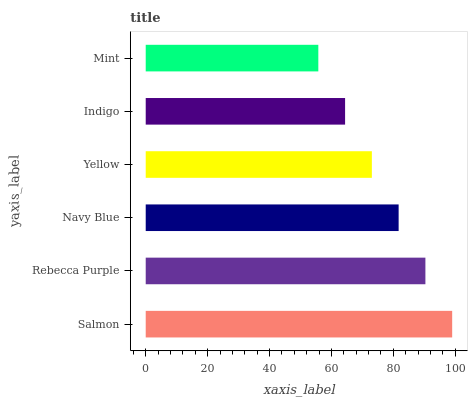Is Mint the minimum?
Answer yes or no. Yes. Is Salmon the maximum?
Answer yes or no. Yes. Is Rebecca Purple the minimum?
Answer yes or no. No. Is Rebecca Purple the maximum?
Answer yes or no. No. Is Salmon greater than Rebecca Purple?
Answer yes or no. Yes. Is Rebecca Purple less than Salmon?
Answer yes or no. Yes. Is Rebecca Purple greater than Salmon?
Answer yes or no. No. Is Salmon less than Rebecca Purple?
Answer yes or no. No. Is Navy Blue the high median?
Answer yes or no. Yes. Is Yellow the low median?
Answer yes or no. Yes. Is Indigo the high median?
Answer yes or no. No. Is Mint the low median?
Answer yes or no. No. 